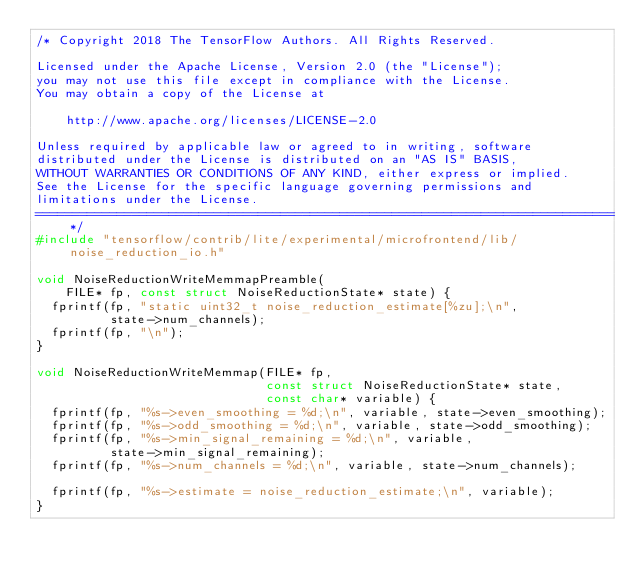<code> <loc_0><loc_0><loc_500><loc_500><_C_>/* Copyright 2018 The TensorFlow Authors. All Rights Reserved.

Licensed under the Apache License, Version 2.0 (the "License");
you may not use this file except in compliance with the License.
You may obtain a copy of the License at

    http://www.apache.org/licenses/LICENSE-2.0

Unless required by applicable law or agreed to in writing, software
distributed under the License is distributed on an "AS IS" BASIS,
WITHOUT WARRANTIES OR CONDITIONS OF ANY KIND, either express or implied.
See the License for the specific language governing permissions and
limitations under the License.
==============================================================================*/
#include "tensorflow/contrib/lite/experimental/microfrontend/lib/noise_reduction_io.h"

void NoiseReductionWriteMemmapPreamble(
    FILE* fp, const struct NoiseReductionState* state) {
  fprintf(fp, "static uint32_t noise_reduction_estimate[%zu];\n",
          state->num_channels);
  fprintf(fp, "\n");
}

void NoiseReductionWriteMemmap(FILE* fp,
                               const struct NoiseReductionState* state,
                               const char* variable) {
  fprintf(fp, "%s->even_smoothing = %d;\n", variable, state->even_smoothing);
  fprintf(fp, "%s->odd_smoothing = %d;\n", variable, state->odd_smoothing);
  fprintf(fp, "%s->min_signal_remaining = %d;\n", variable,
          state->min_signal_remaining);
  fprintf(fp, "%s->num_channels = %d;\n", variable, state->num_channels);

  fprintf(fp, "%s->estimate = noise_reduction_estimate;\n", variable);
}
</code> 